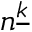<formula> <loc_0><loc_0><loc_500><loc_500>n ^ { \underline { k } }</formula> 